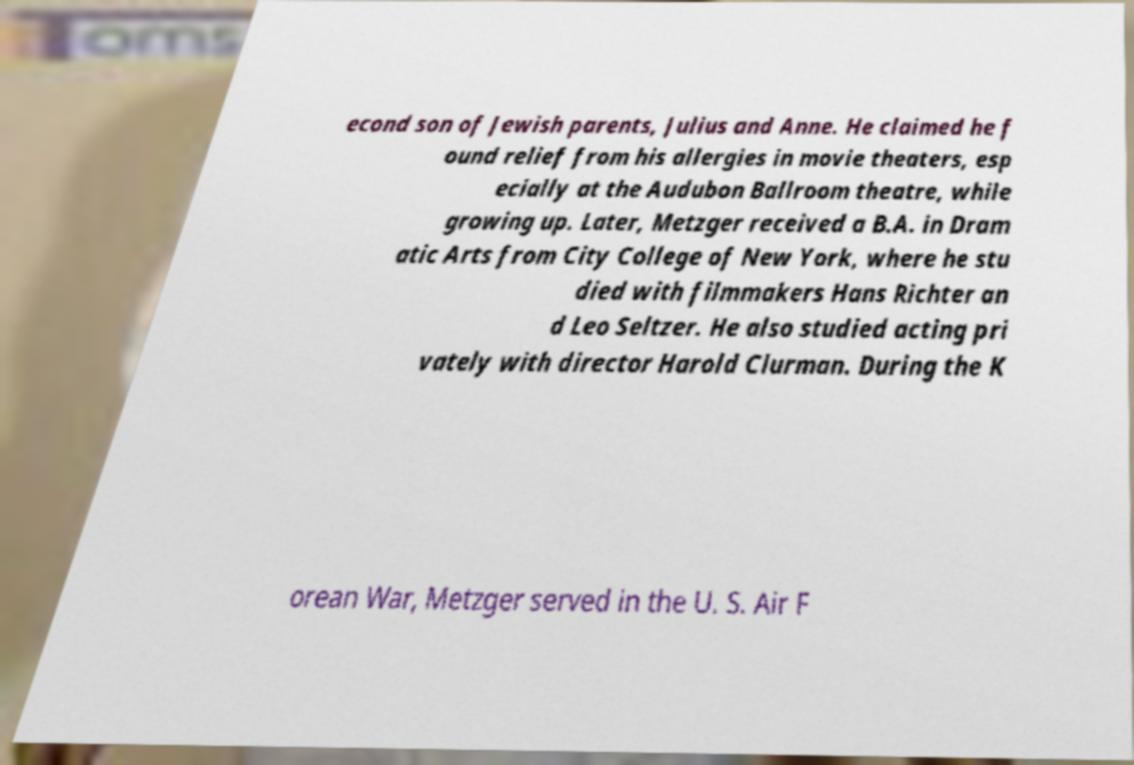Could you extract and type out the text from this image? econd son of Jewish parents, Julius and Anne. He claimed he f ound relief from his allergies in movie theaters, esp ecially at the Audubon Ballroom theatre, while growing up. Later, Metzger received a B.A. in Dram atic Arts from City College of New York, where he stu died with filmmakers Hans Richter an d Leo Seltzer. He also studied acting pri vately with director Harold Clurman. During the K orean War, Metzger served in the U. S. Air F 